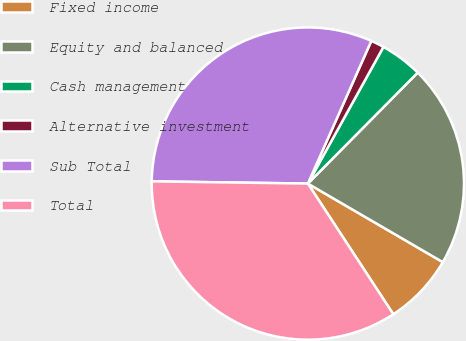<chart> <loc_0><loc_0><loc_500><loc_500><pie_chart><fcel>Fixed income<fcel>Equity and balanced<fcel>Cash management<fcel>Alternative investment<fcel>Sub Total<fcel>Total<nl><fcel>7.39%<fcel>20.97%<fcel>4.38%<fcel>1.38%<fcel>31.43%<fcel>34.44%<nl></chart> 